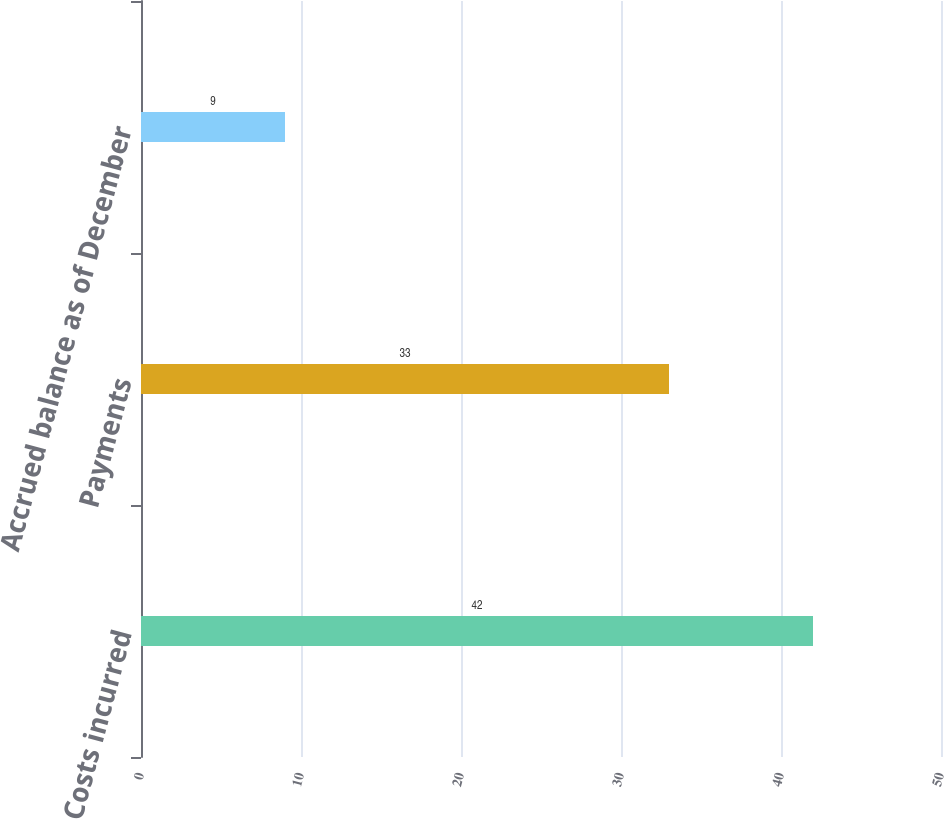Convert chart to OTSL. <chart><loc_0><loc_0><loc_500><loc_500><bar_chart><fcel>Costs incurred<fcel>Payments<fcel>Accrued balance as of December<nl><fcel>42<fcel>33<fcel>9<nl></chart> 